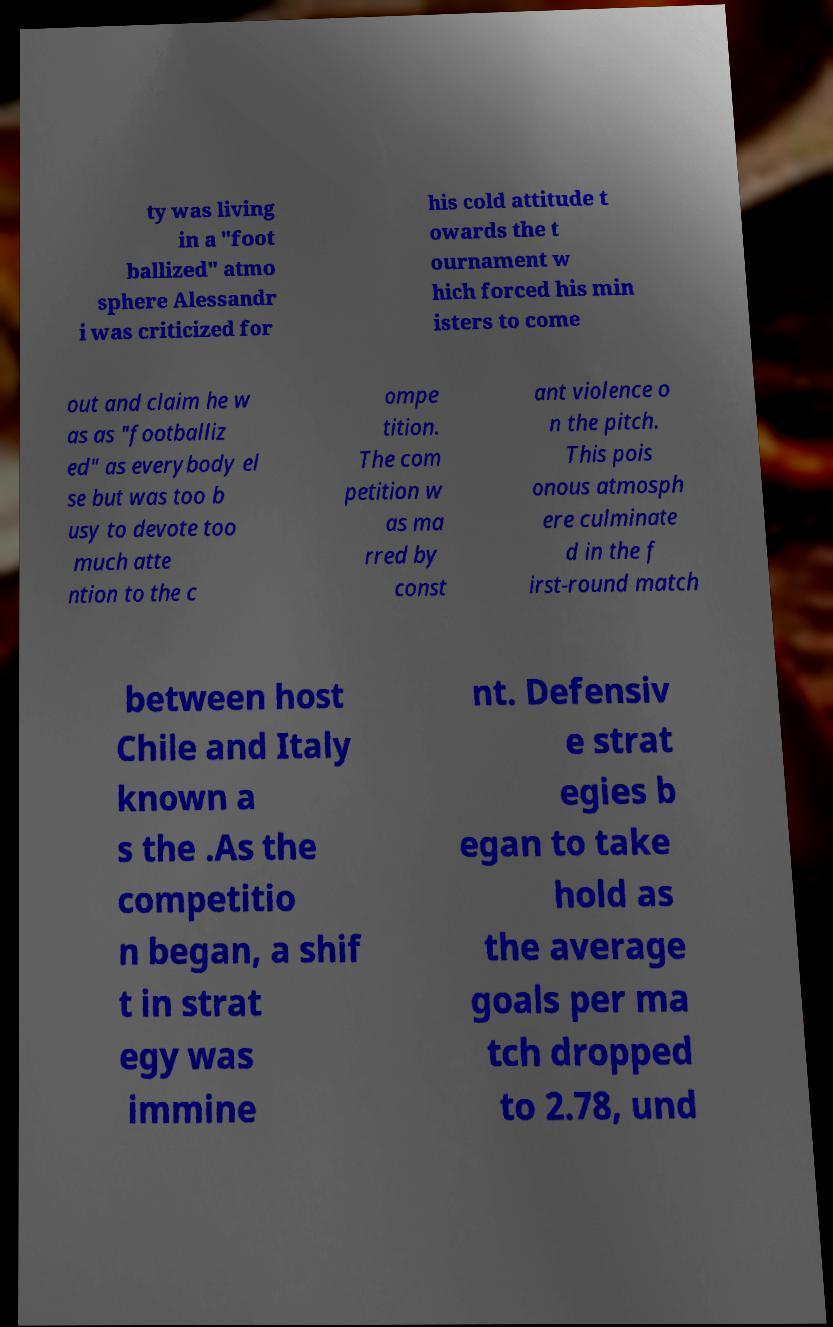There's text embedded in this image that I need extracted. Can you transcribe it verbatim? ty was living in a "foot ballized" atmo sphere Alessandr i was criticized for his cold attitude t owards the t ournament w hich forced his min isters to come out and claim he w as as "footballiz ed" as everybody el se but was too b usy to devote too much atte ntion to the c ompe tition. The com petition w as ma rred by const ant violence o n the pitch. This pois onous atmosph ere culminate d in the f irst-round match between host Chile and Italy known a s the .As the competitio n began, a shif t in strat egy was immine nt. Defensiv e strat egies b egan to take hold as the average goals per ma tch dropped to 2.78, und 